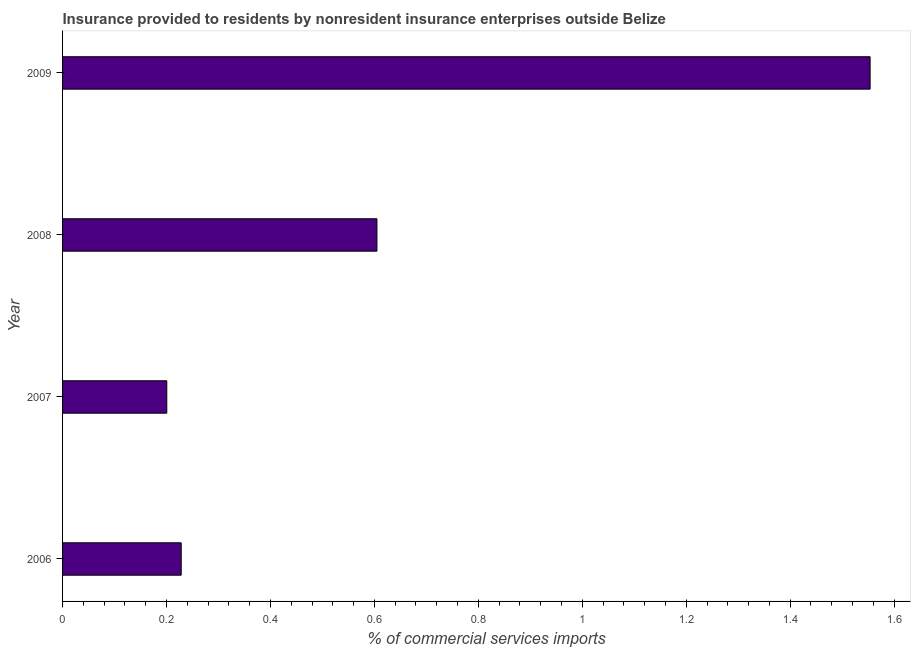What is the title of the graph?
Your response must be concise. Insurance provided to residents by nonresident insurance enterprises outside Belize. What is the label or title of the X-axis?
Your answer should be compact. % of commercial services imports. What is the insurance provided by non-residents in 2006?
Give a very brief answer. 0.23. Across all years, what is the maximum insurance provided by non-residents?
Keep it short and to the point. 1.55. Across all years, what is the minimum insurance provided by non-residents?
Provide a short and direct response. 0.2. What is the sum of the insurance provided by non-residents?
Offer a terse response. 2.59. What is the difference between the insurance provided by non-residents in 2008 and 2009?
Give a very brief answer. -0.95. What is the average insurance provided by non-residents per year?
Offer a very short reply. 0.65. What is the median insurance provided by non-residents?
Give a very brief answer. 0.42. In how many years, is the insurance provided by non-residents greater than 1.08 %?
Your answer should be compact. 1. Do a majority of the years between 2006 and 2007 (inclusive) have insurance provided by non-residents greater than 0.76 %?
Provide a succinct answer. No. What is the ratio of the insurance provided by non-residents in 2006 to that in 2007?
Provide a short and direct response. 1.14. What is the difference between the highest and the second highest insurance provided by non-residents?
Offer a very short reply. 0.95. Is the sum of the insurance provided by non-residents in 2007 and 2009 greater than the maximum insurance provided by non-residents across all years?
Keep it short and to the point. Yes. What is the difference between the highest and the lowest insurance provided by non-residents?
Provide a succinct answer. 1.35. How many years are there in the graph?
Provide a short and direct response. 4. What is the % of commercial services imports of 2006?
Keep it short and to the point. 0.23. What is the % of commercial services imports in 2007?
Make the answer very short. 0.2. What is the % of commercial services imports in 2008?
Keep it short and to the point. 0.6. What is the % of commercial services imports in 2009?
Offer a very short reply. 1.55. What is the difference between the % of commercial services imports in 2006 and 2007?
Give a very brief answer. 0.03. What is the difference between the % of commercial services imports in 2006 and 2008?
Provide a short and direct response. -0.38. What is the difference between the % of commercial services imports in 2006 and 2009?
Ensure brevity in your answer.  -1.33. What is the difference between the % of commercial services imports in 2007 and 2008?
Offer a terse response. -0.4. What is the difference between the % of commercial services imports in 2007 and 2009?
Your answer should be compact. -1.35. What is the difference between the % of commercial services imports in 2008 and 2009?
Your answer should be very brief. -0.95. What is the ratio of the % of commercial services imports in 2006 to that in 2007?
Give a very brief answer. 1.14. What is the ratio of the % of commercial services imports in 2006 to that in 2008?
Offer a very short reply. 0.38. What is the ratio of the % of commercial services imports in 2006 to that in 2009?
Keep it short and to the point. 0.15. What is the ratio of the % of commercial services imports in 2007 to that in 2008?
Offer a very short reply. 0.33. What is the ratio of the % of commercial services imports in 2007 to that in 2009?
Your answer should be compact. 0.13. What is the ratio of the % of commercial services imports in 2008 to that in 2009?
Offer a terse response. 0.39. 